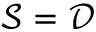<formula> <loc_0><loc_0><loc_500><loc_500>{ \mathcal { S } } = { \mathcal { D } }</formula> 